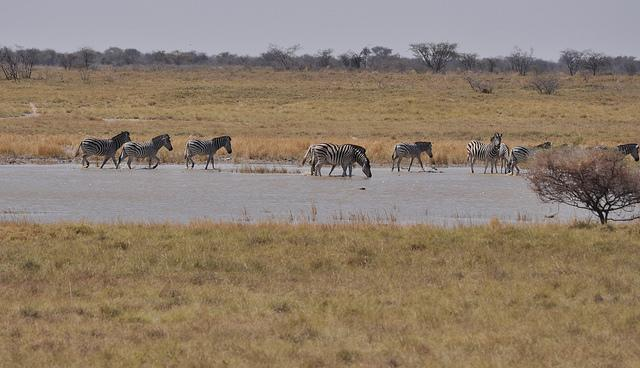What direction are the animals facing?

Choices:
A) south
B) west
C) east
D) north east 